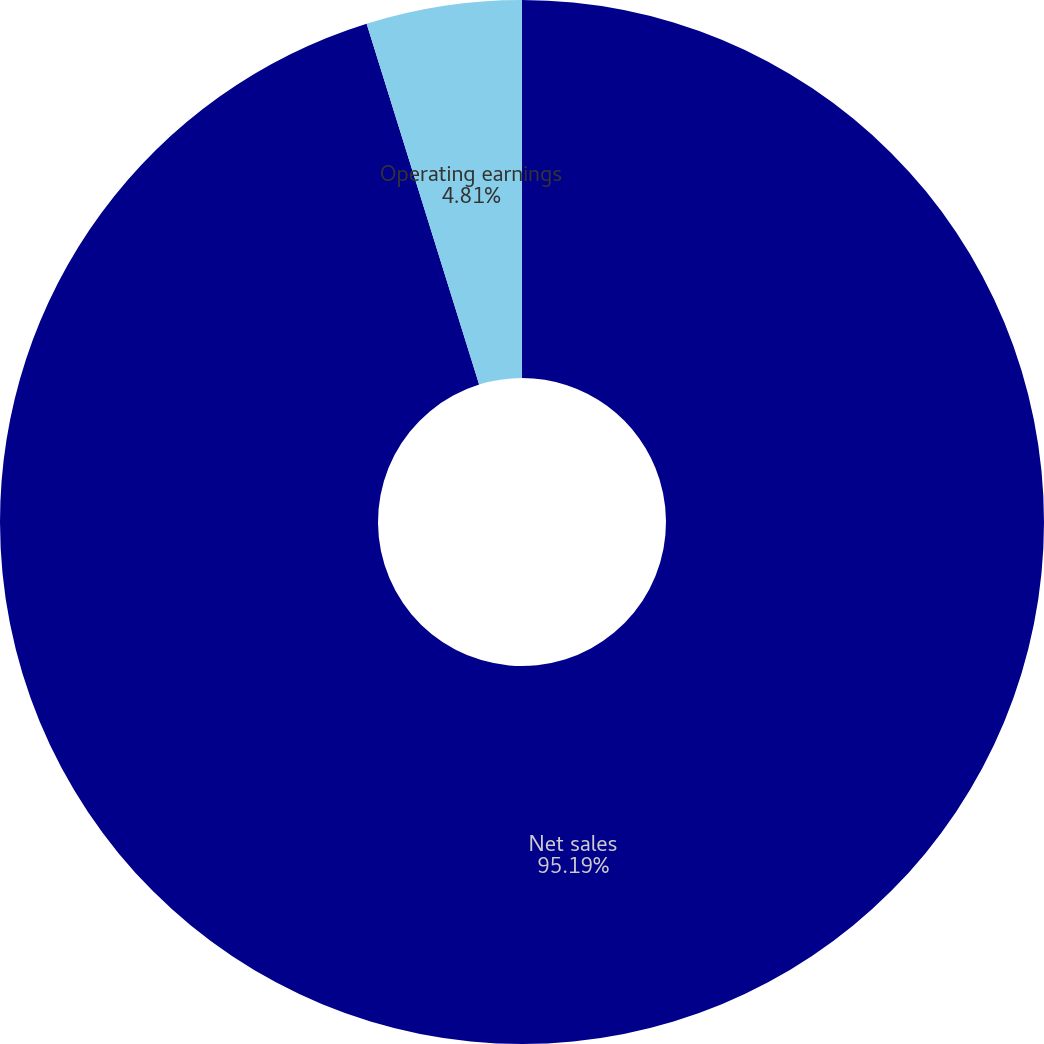Convert chart to OTSL. <chart><loc_0><loc_0><loc_500><loc_500><pie_chart><fcel>Net sales<fcel>Operating earnings<nl><fcel>95.19%<fcel>4.81%<nl></chart> 